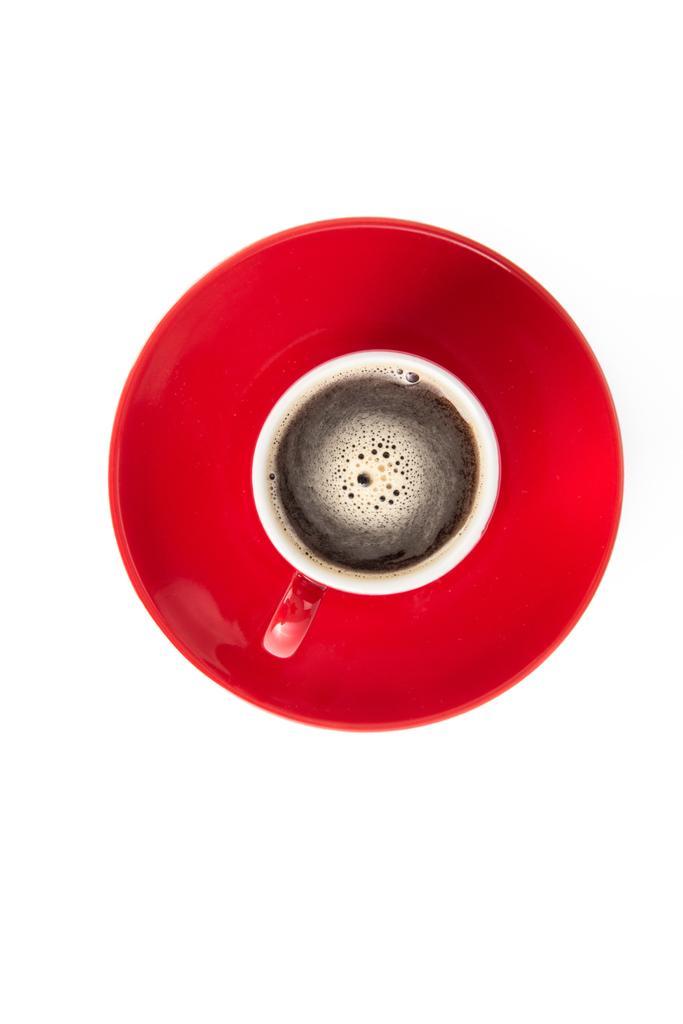Can you describe this image briefly? In this image I can see the cup with drink in it. It is on the plate which is in red color. And there is a white background. 